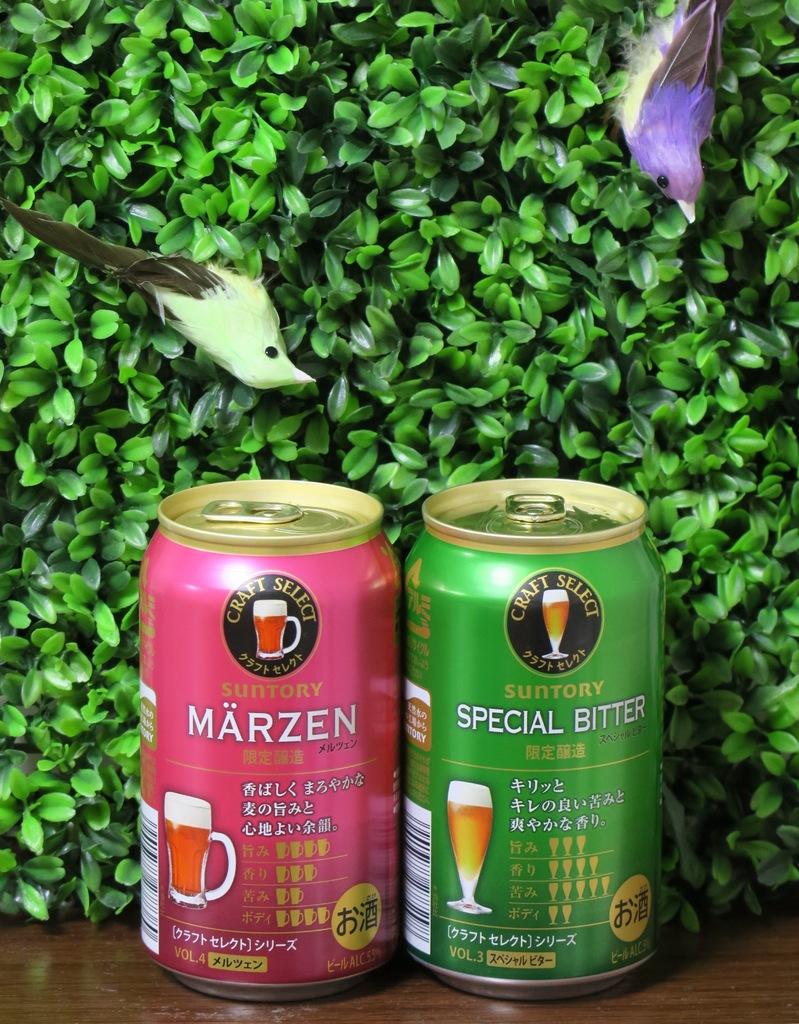What is the name on the pink can?
Your answer should be compact. Marzen. 